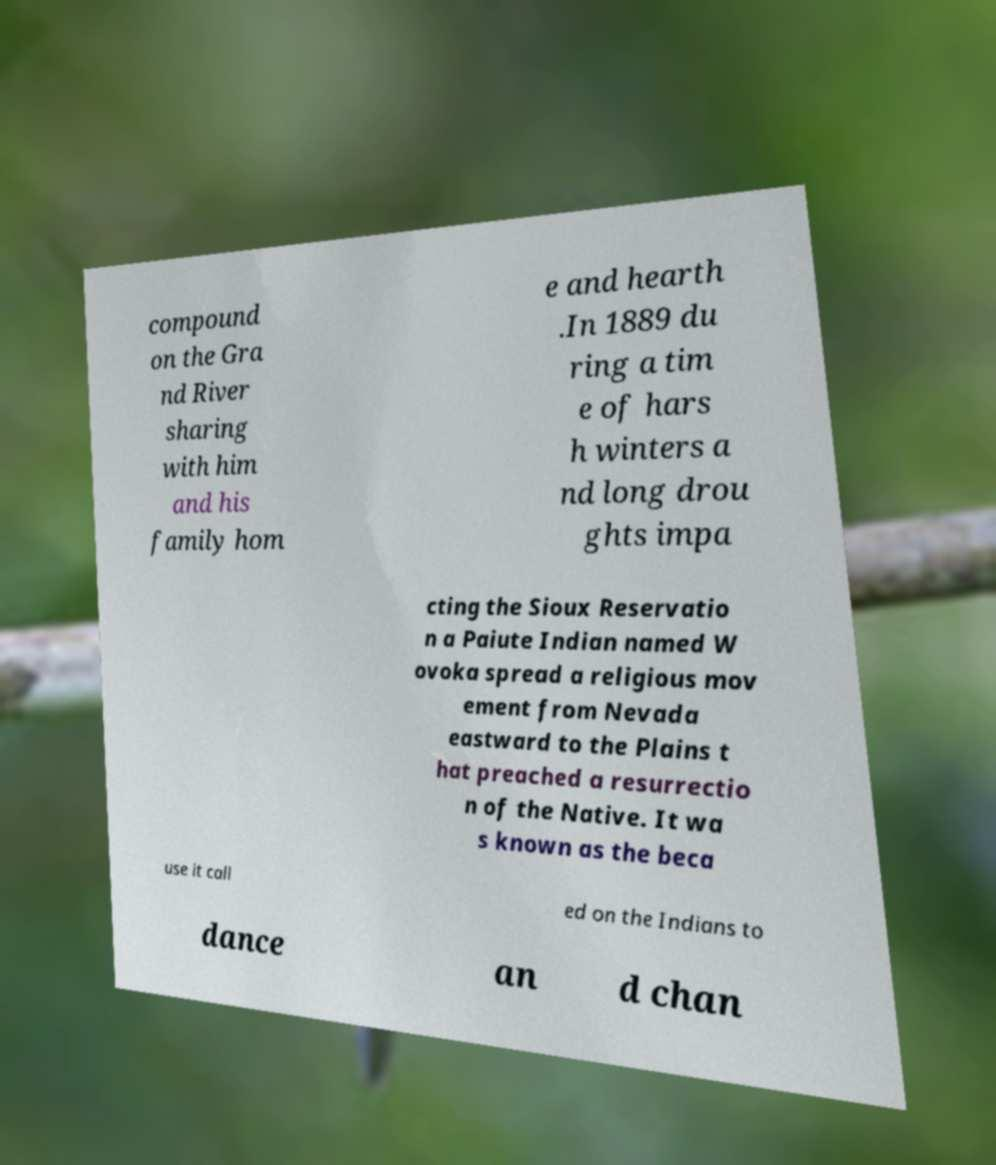Can you read and provide the text displayed in the image?This photo seems to have some interesting text. Can you extract and type it out for me? compound on the Gra nd River sharing with him and his family hom e and hearth .In 1889 du ring a tim e of hars h winters a nd long drou ghts impa cting the Sioux Reservatio n a Paiute Indian named W ovoka spread a religious mov ement from Nevada eastward to the Plains t hat preached a resurrectio n of the Native. It wa s known as the beca use it call ed on the Indians to dance an d chan 